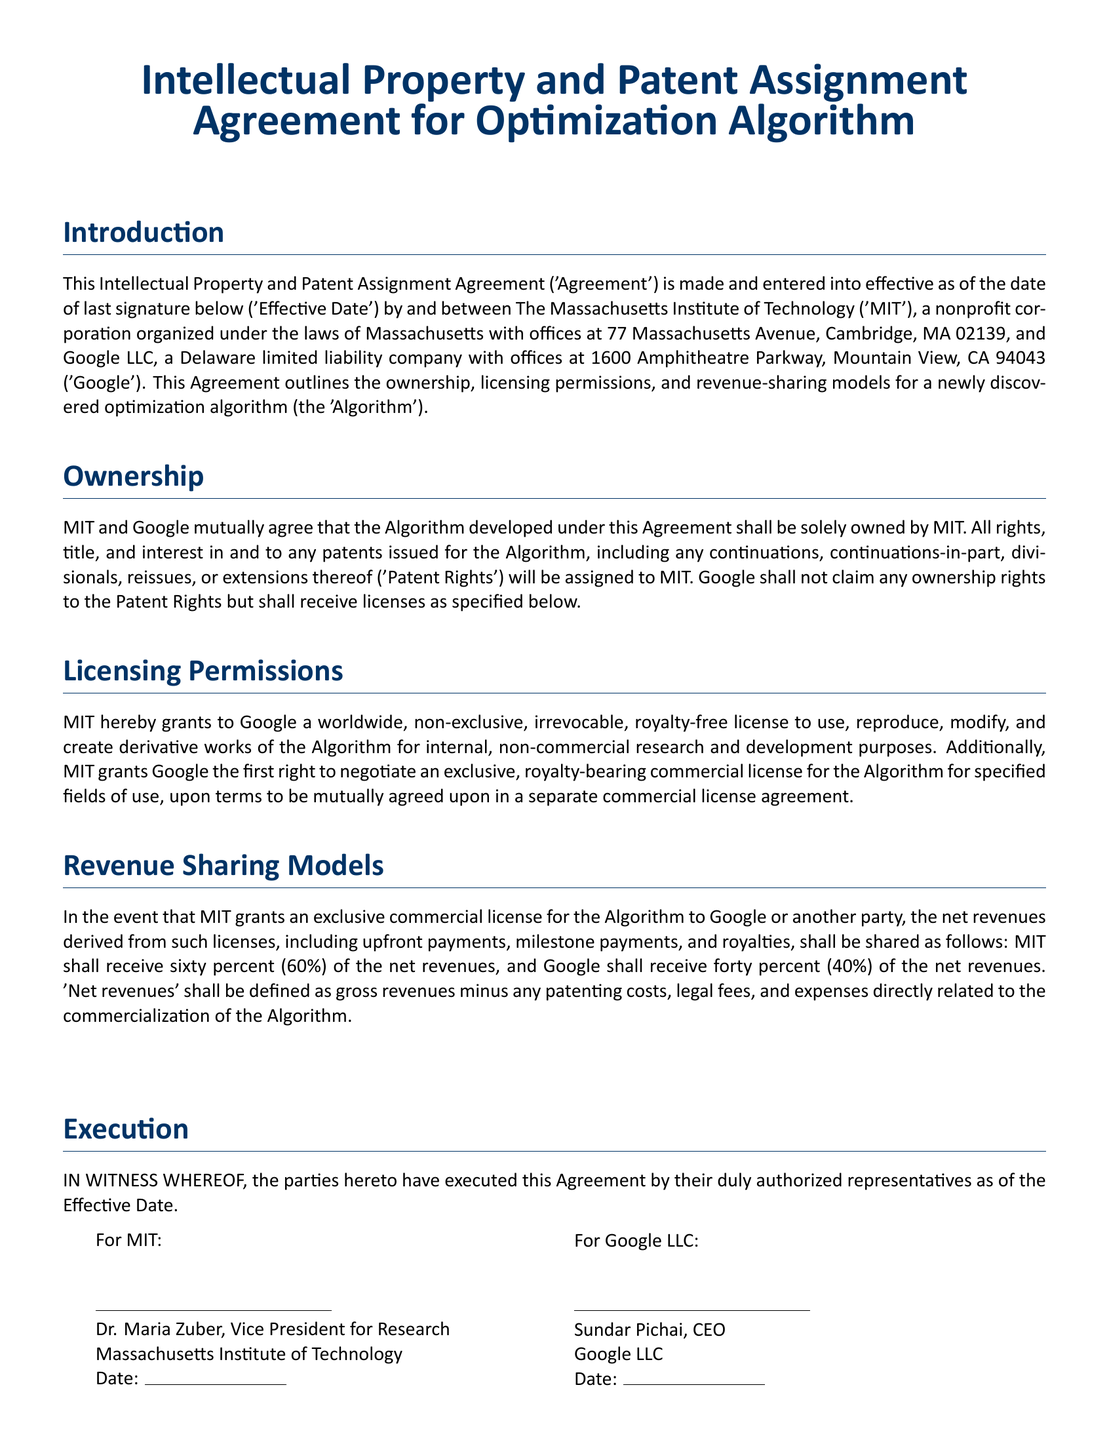what is the name of the optimization algorithm? The optimization algorithm is referred to as 'the Algorithm' in the document.
Answer: the Algorithm who are the parties involved in the agreement? The parties involved in the agreement are The Massachusetts Institute of Technology and Google LLC.
Answer: MIT and Google who is the Vice President for Research at MIT? The document states that the Vice President for Research at MIT is Dr. Maria Zuber.
Answer: Dr. Maria Zuber what percentage of net revenues does MIT receive? The agreement specifies that MIT shall receive sixty percent of the net revenues derived from licenses.
Answer: sixty percent what kind of license does MIT grant to Google? MIT grants Google a worldwide, non-exclusive, irrevocable, royalty-free license for specific purposes.
Answer: worldwide, non-exclusive, irrevocable, royalty-free license what rights does Google have regarding the commercial license? Google has the first right to negotiate an exclusive, royalty-bearing commercial license for the Algorithm.
Answer: first right to negotiate an exclusive, royalty-bearing commercial license what is the location of Google LLC's offices? The location of Google LLC's offices is detailed as 1600 Amphitheatre Parkway, Mountain View, CA 94043.
Answer: 1600 Amphitheatre Parkway, Mountain View, CA 94043 when was the agreement effective? The effective date of the agreement is indicated as the date of last signature below.
Answer: date of last signature below how are 'net revenues' defined in the document? 'Net revenues' are defined as gross revenues minus specific related costs and expenses.
Answer: gross revenues minus any patenting costs, legal fees, and expenses directly related to the commercialization of the Algorithm 